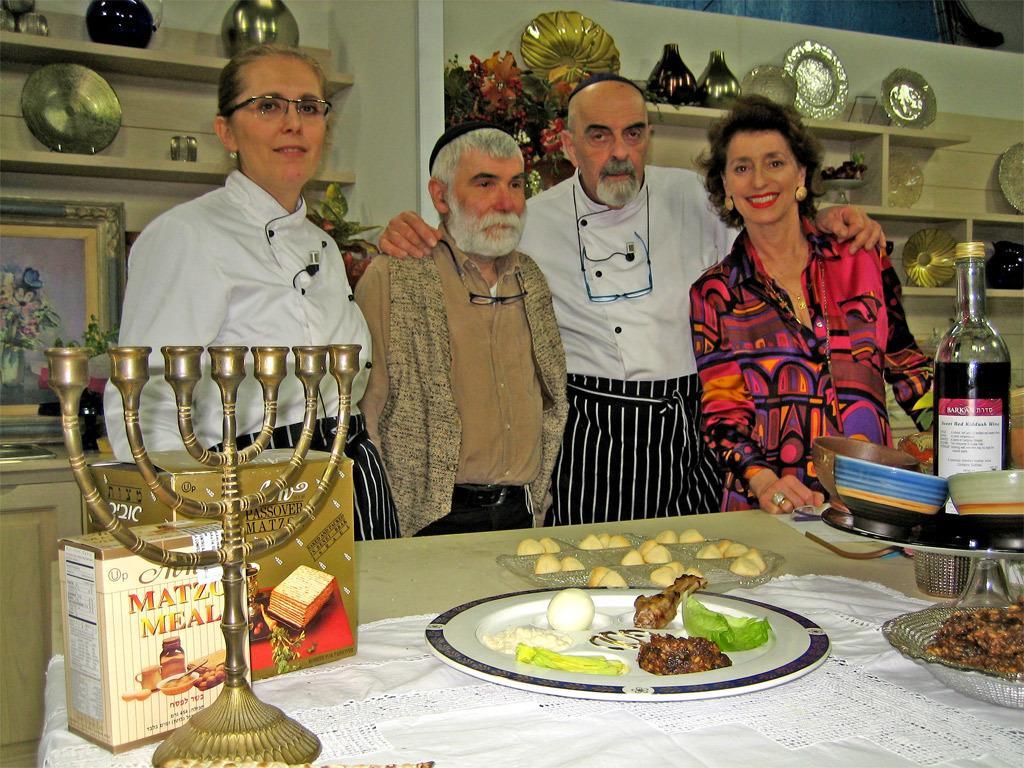Please provide a concise description of this image. In this image I can see few people. There are few food items on the table. In the background there is a shelf. 